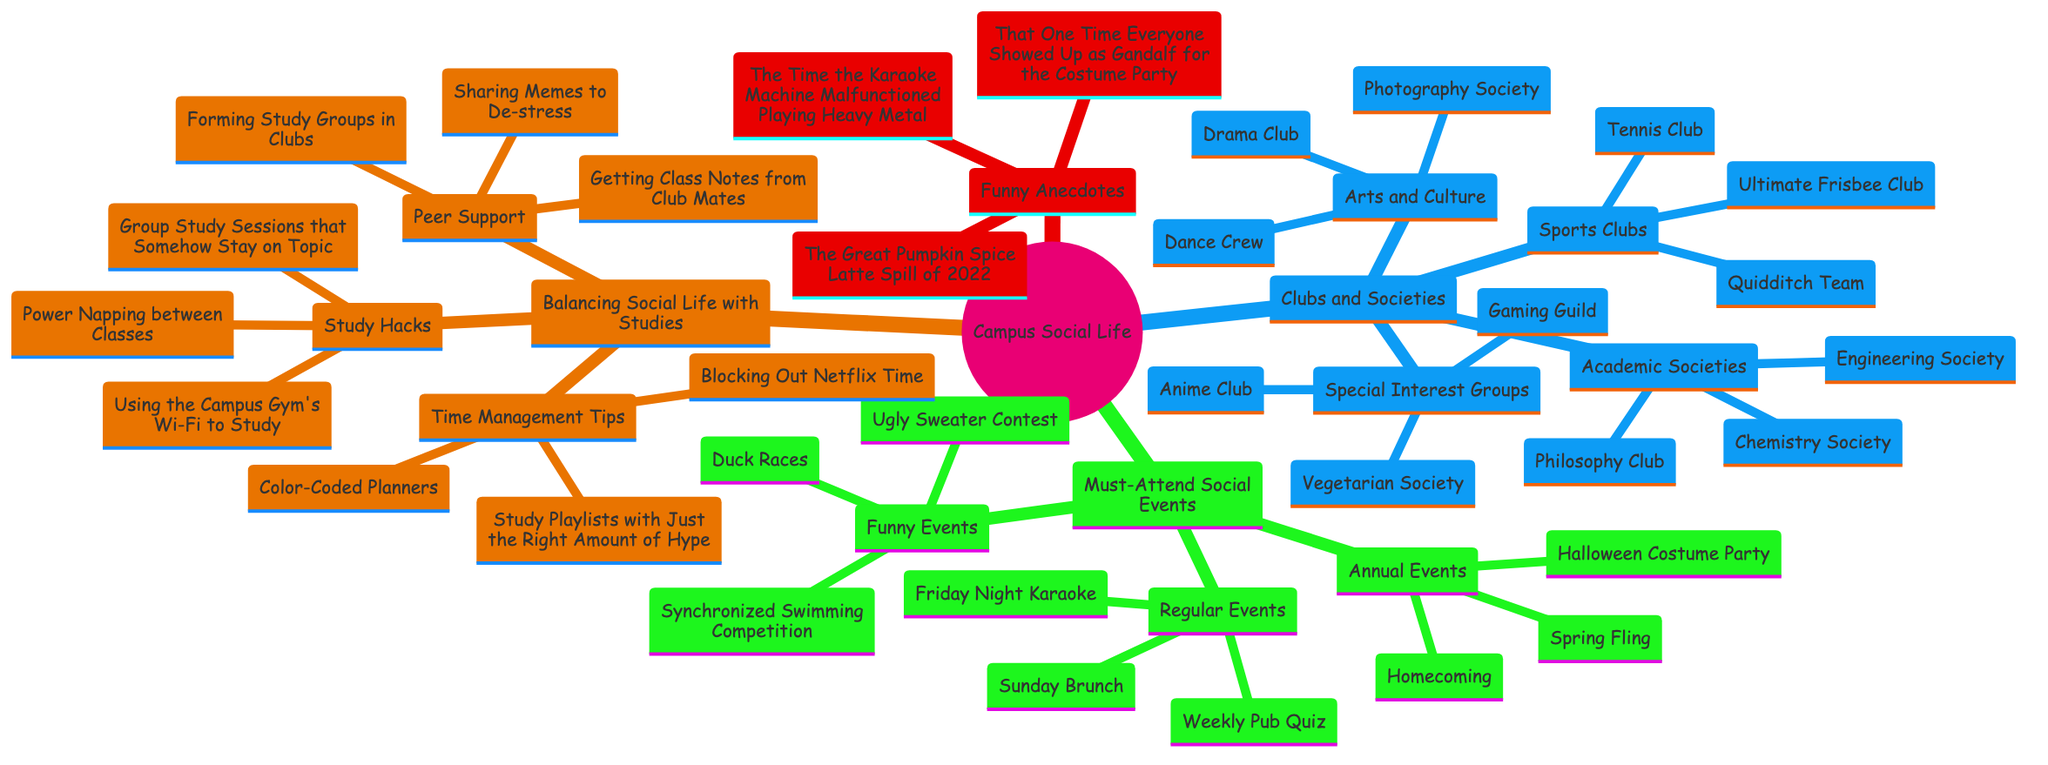What clubs are listed under Special Interest Groups? The diagram shows under the "Special Interest Groups" category, three clubs are listed: "Gaming Guild," "Anime Club," and "Vegetarian Society." This information is directly extracted from the respective section of the diagram.
Answer: Gaming Guild, Anime Club, Vegetarian Society How many must-attend social events are listed? To determine the total number of events, we need to count the events within each category: Regular Events (3), Annual Events (3), and Funny Events (3), resulting in 3 + 3 + 3 = 9 events in total.
Answer: 9 What funny event involves swimming? The only funny event that mentions swimming in the diagram is the "Synchronized Swimming Competition." This is explicitly stated in the "Funny Events" section.
Answer: Synchronized Swimming Competition Which academic society focuses on philosophy? The diagram indicates that the "Philosophy Club" is the academic society related to philosophy, as it is listed under the "Academic Societies" heading.
Answer: Philosophy Club How many study hacks are mentioned in the diagram? In the "Study Hacks" section, there are three items listed: "Power Napping between Classes," "Group Study Sessions that Somehow Stay on Topic," and "Using the Campus Gym's Wi-Fi to Study." Therefore, there are a total of 3 study hacks mentioned.
Answer: 3 What was the humorous incident related to a costume party? The humorous incident described in the diagram that relates to a costume party states, "That One Time Everyone Showed Up as Gandalf for the Costume Party," which can be found under "Funny Anecdotes from Past Events."
Answer: That One Time Everyone Showed Up as Gandalf for the Costume Party Which time management tip involves Netflix? The time management tip that mentions Netflix is "Blocking Out Netflix Time," listed under the "Time Management Tips" section of the diagram.
Answer: Blocking Out Netflix Time What sport is represented by the Quidditch Team? The Quidditch Team represents the sport of Quidditch, which is specifically mentioned under the "Sports Clubs" category in the "Clubs and Societies" section.
Answer: Quidditch 